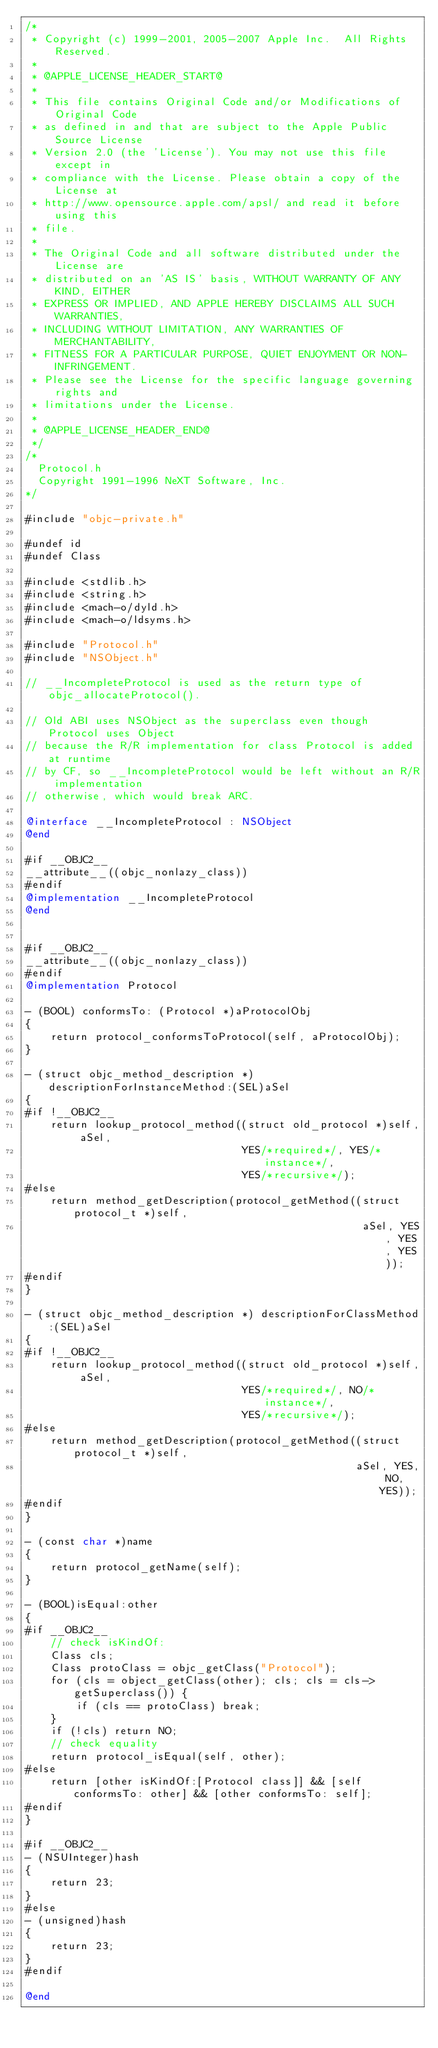Convert code to text. <code><loc_0><loc_0><loc_500><loc_500><_ObjectiveC_>/*
 * Copyright (c) 1999-2001, 2005-2007 Apple Inc.  All Rights Reserved.
 * 
 * @APPLE_LICENSE_HEADER_START@
 * 
 * This file contains Original Code and/or Modifications of Original Code
 * as defined in and that are subject to the Apple Public Source License
 * Version 2.0 (the 'License'). You may not use this file except in
 * compliance with the License. Please obtain a copy of the License at
 * http://www.opensource.apple.com/apsl/ and read it before using this
 * file.
 * 
 * The Original Code and all software distributed under the License are
 * distributed on an 'AS IS' basis, WITHOUT WARRANTY OF ANY KIND, EITHER
 * EXPRESS OR IMPLIED, AND APPLE HEREBY DISCLAIMS ALL SUCH WARRANTIES,
 * INCLUDING WITHOUT LIMITATION, ANY WARRANTIES OF MERCHANTABILITY,
 * FITNESS FOR A PARTICULAR PURPOSE, QUIET ENJOYMENT OR NON-INFRINGEMENT.
 * Please see the License for the specific language governing rights and
 * limitations under the License.
 * 
 * @APPLE_LICENSE_HEADER_END@
 */
/*
	Protocol.h
	Copyright 1991-1996 NeXT Software, Inc.
*/

#include "objc-private.h"

#undef id
#undef Class

#include <stdlib.h>
#include <string.h>
#include <mach-o/dyld.h>
#include <mach-o/ldsyms.h>

#include "Protocol.h"
#include "NSObject.h"

// __IncompleteProtocol is used as the return type of objc_allocateProtocol().

// Old ABI uses NSObject as the superclass even though Protocol uses Object
// because the R/R implementation for class Protocol is added at runtime
// by CF, so __IncompleteProtocol would be left without an R/R implementation 
// otherwise, which would break ARC.

@interface __IncompleteProtocol : NSObject
@end

#if __OBJC2__
__attribute__((objc_nonlazy_class))
#endif
@implementation __IncompleteProtocol
@end


#if __OBJC2__
__attribute__((objc_nonlazy_class))
#endif
@implementation Protocol

- (BOOL) conformsTo: (Protocol *)aProtocolObj
{
    return protocol_conformsToProtocol(self, aProtocolObj);
}

- (struct objc_method_description *) descriptionForInstanceMethod:(SEL)aSel
{
#if !__OBJC2__
    return lookup_protocol_method((struct old_protocol *)self, aSel, 
                                  YES/*required*/, YES/*instance*/, 
                                  YES/*recursive*/);
#else
    return method_getDescription(protocol_getMethod((struct protocol_t *)self, 
                                                     aSel, YES, YES, YES));
#endif
}

- (struct objc_method_description *) descriptionForClassMethod:(SEL)aSel
{
#if !__OBJC2__
    return lookup_protocol_method((struct old_protocol *)self, aSel, 
                                  YES/*required*/, NO/*instance*/, 
                                  YES/*recursive*/);
#else
    return method_getDescription(protocol_getMethod((struct protocol_t *)self, 
                                                    aSel, YES, NO, YES));
#endif
}

- (const char *)name
{
    return protocol_getName(self);
}

- (BOOL)isEqual:other
{
#if __OBJC2__
    // check isKindOf:
    Class cls;
    Class protoClass = objc_getClass("Protocol");
    for (cls = object_getClass(other); cls; cls = cls->getSuperclass()) {
        if (cls == protoClass) break;
    }
    if (!cls) return NO;
    // check equality
    return protocol_isEqual(self, other);
#else
    return [other isKindOf:[Protocol class]] && [self conformsTo: other] && [other conformsTo: self];
#endif
}

#if __OBJC2__
- (NSUInteger)hash
{
    return 23;
}
#else
- (unsigned)hash
{
    return 23;
}
#endif

@end
</code> 